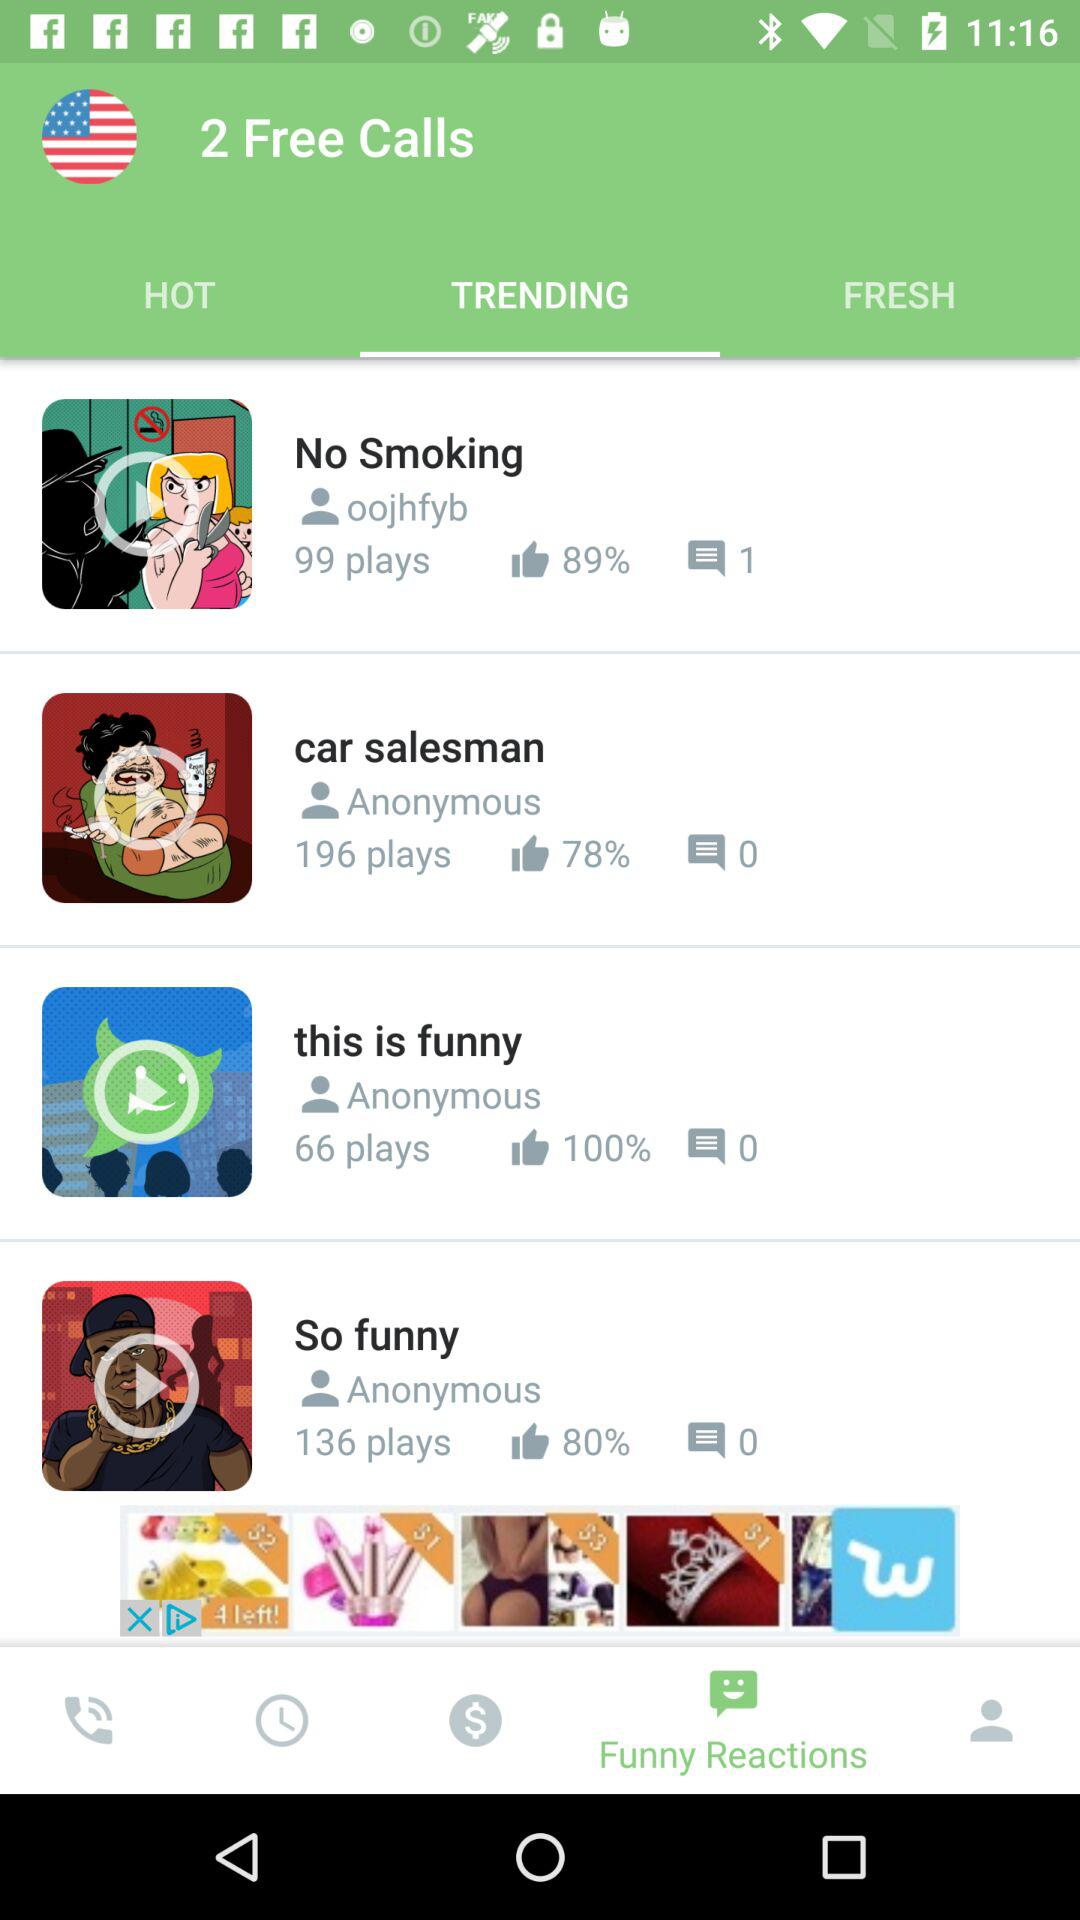What is the percentage of likes of the video "No Smoking"? The percentage is 89. 